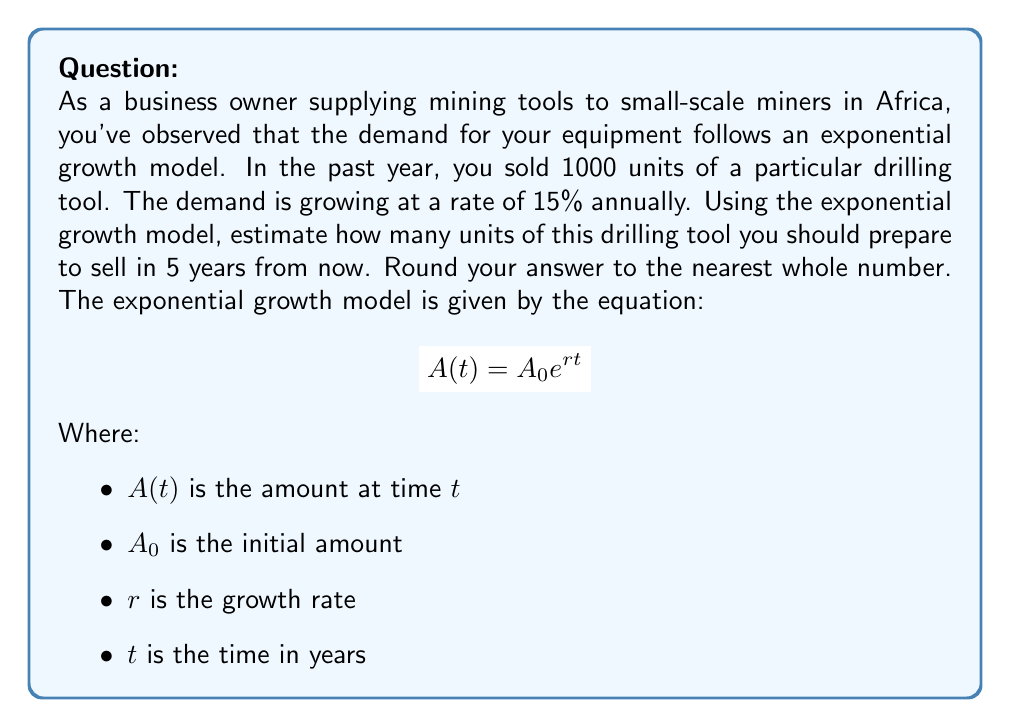Teach me how to tackle this problem. To solve this problem, we'll use the exponential growth model:

$$A(t) = A_0 e^{rt}$$

Given:
- Initial amount, $A_0 = 1000$ units
- Growth rate, $r = 15\% = 0.15$
- Time, $t = 5$ years

Step 1: Substitute the values into the equation:
$$A(5) = 1000 \cdot e^{0.15 \cdot 5}$$

Step 2: Simplify the exponent:
$$A(5) = 1000 \cdot e^{0.75}$$

Step 3: Calculate $e^{0.75}$ (you can use a calculator for this):
$$e^{0.75} \approx 2.117000016$$

Step 4: Multiply by the initial amount:
$$A(5) = 1000 \cdot 2.117000016 = 2117.000016$$

Step 5: Round to the nearest whole number:
$$A(5) \approx 2117 \text{ units}$$

Therefore, you should prepare to sell approximately 2117 units of the drilling tool in 5 years.
Answer: 2117 units 